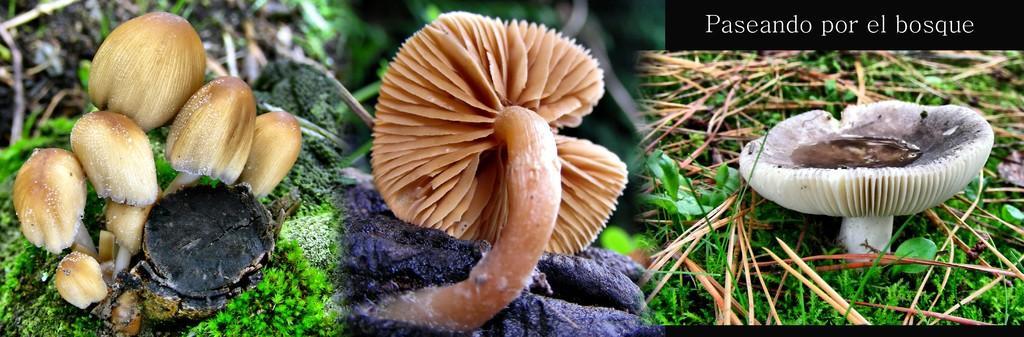Please provide a concise description of this image. I see collage pictures in this image and I see the plants and I see something is written on the right top of this image. 